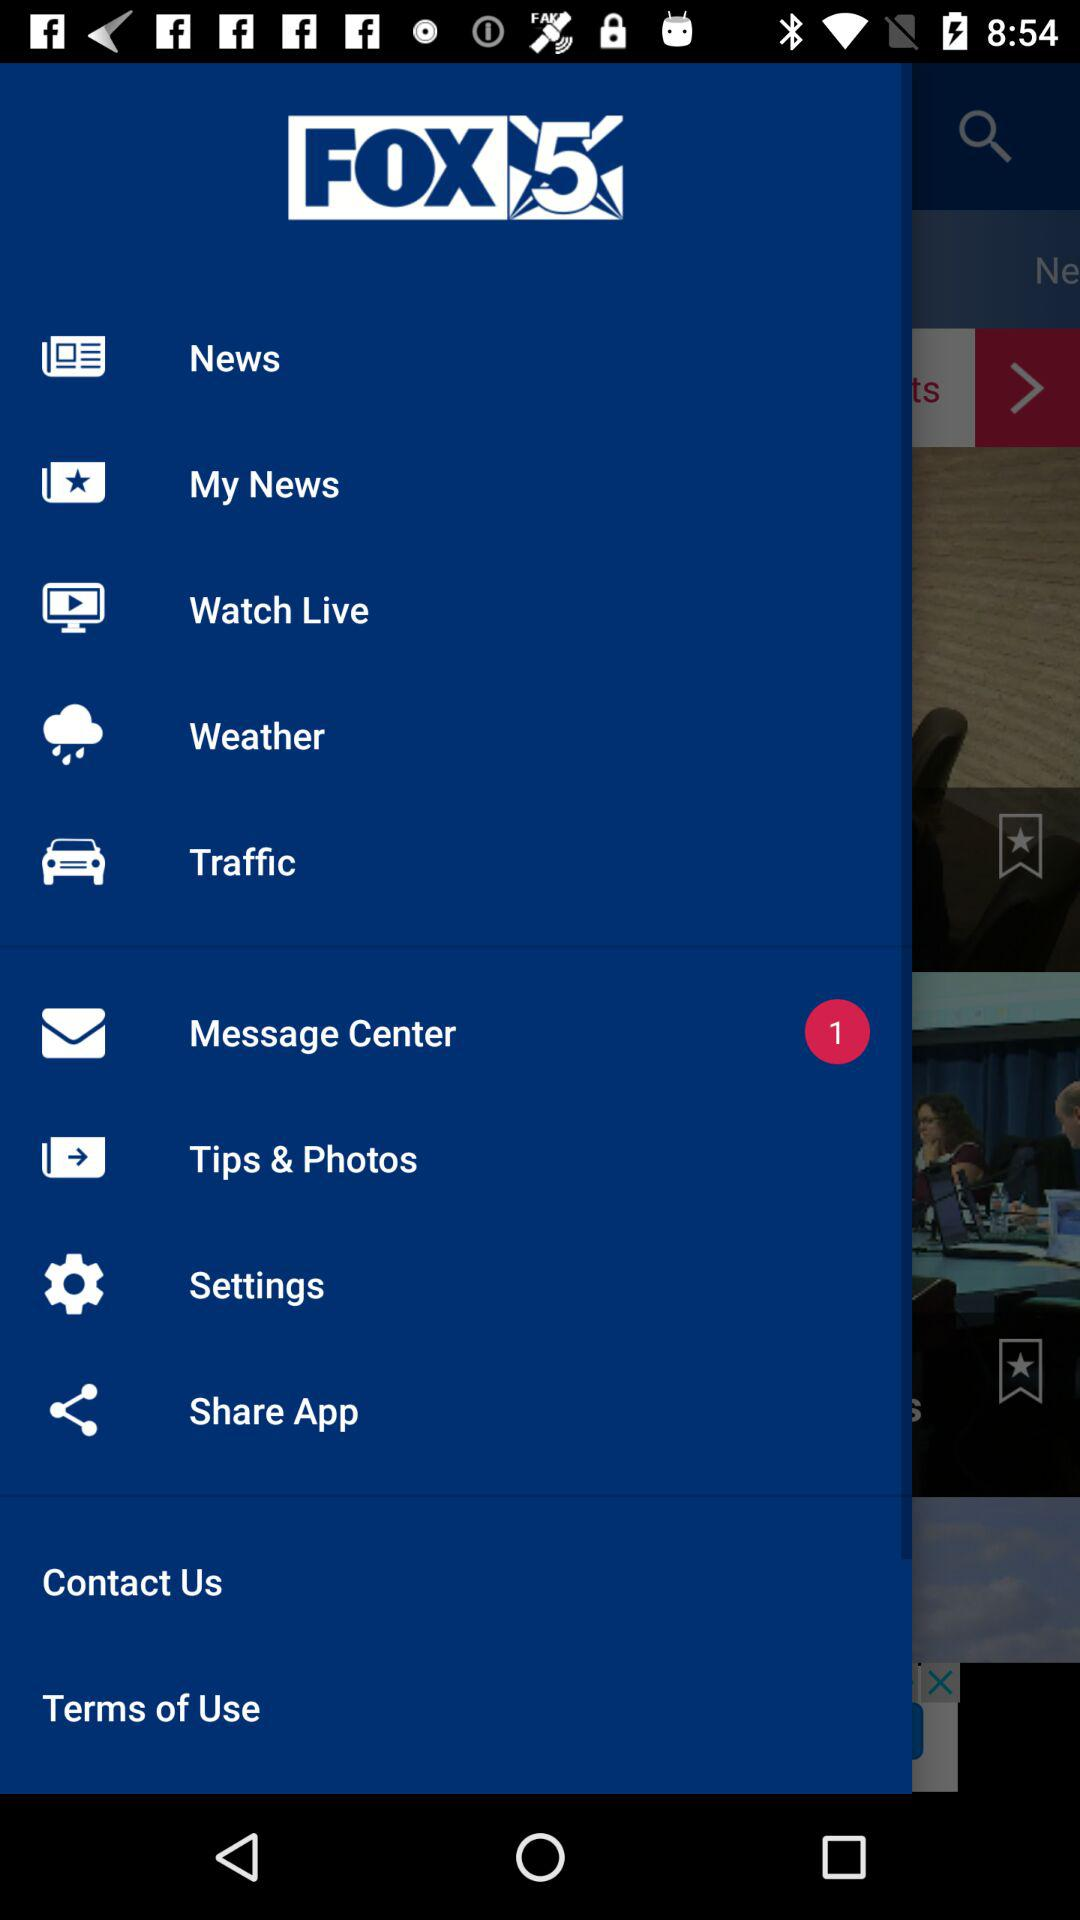What is the application name? The application name is "FOX 5". 